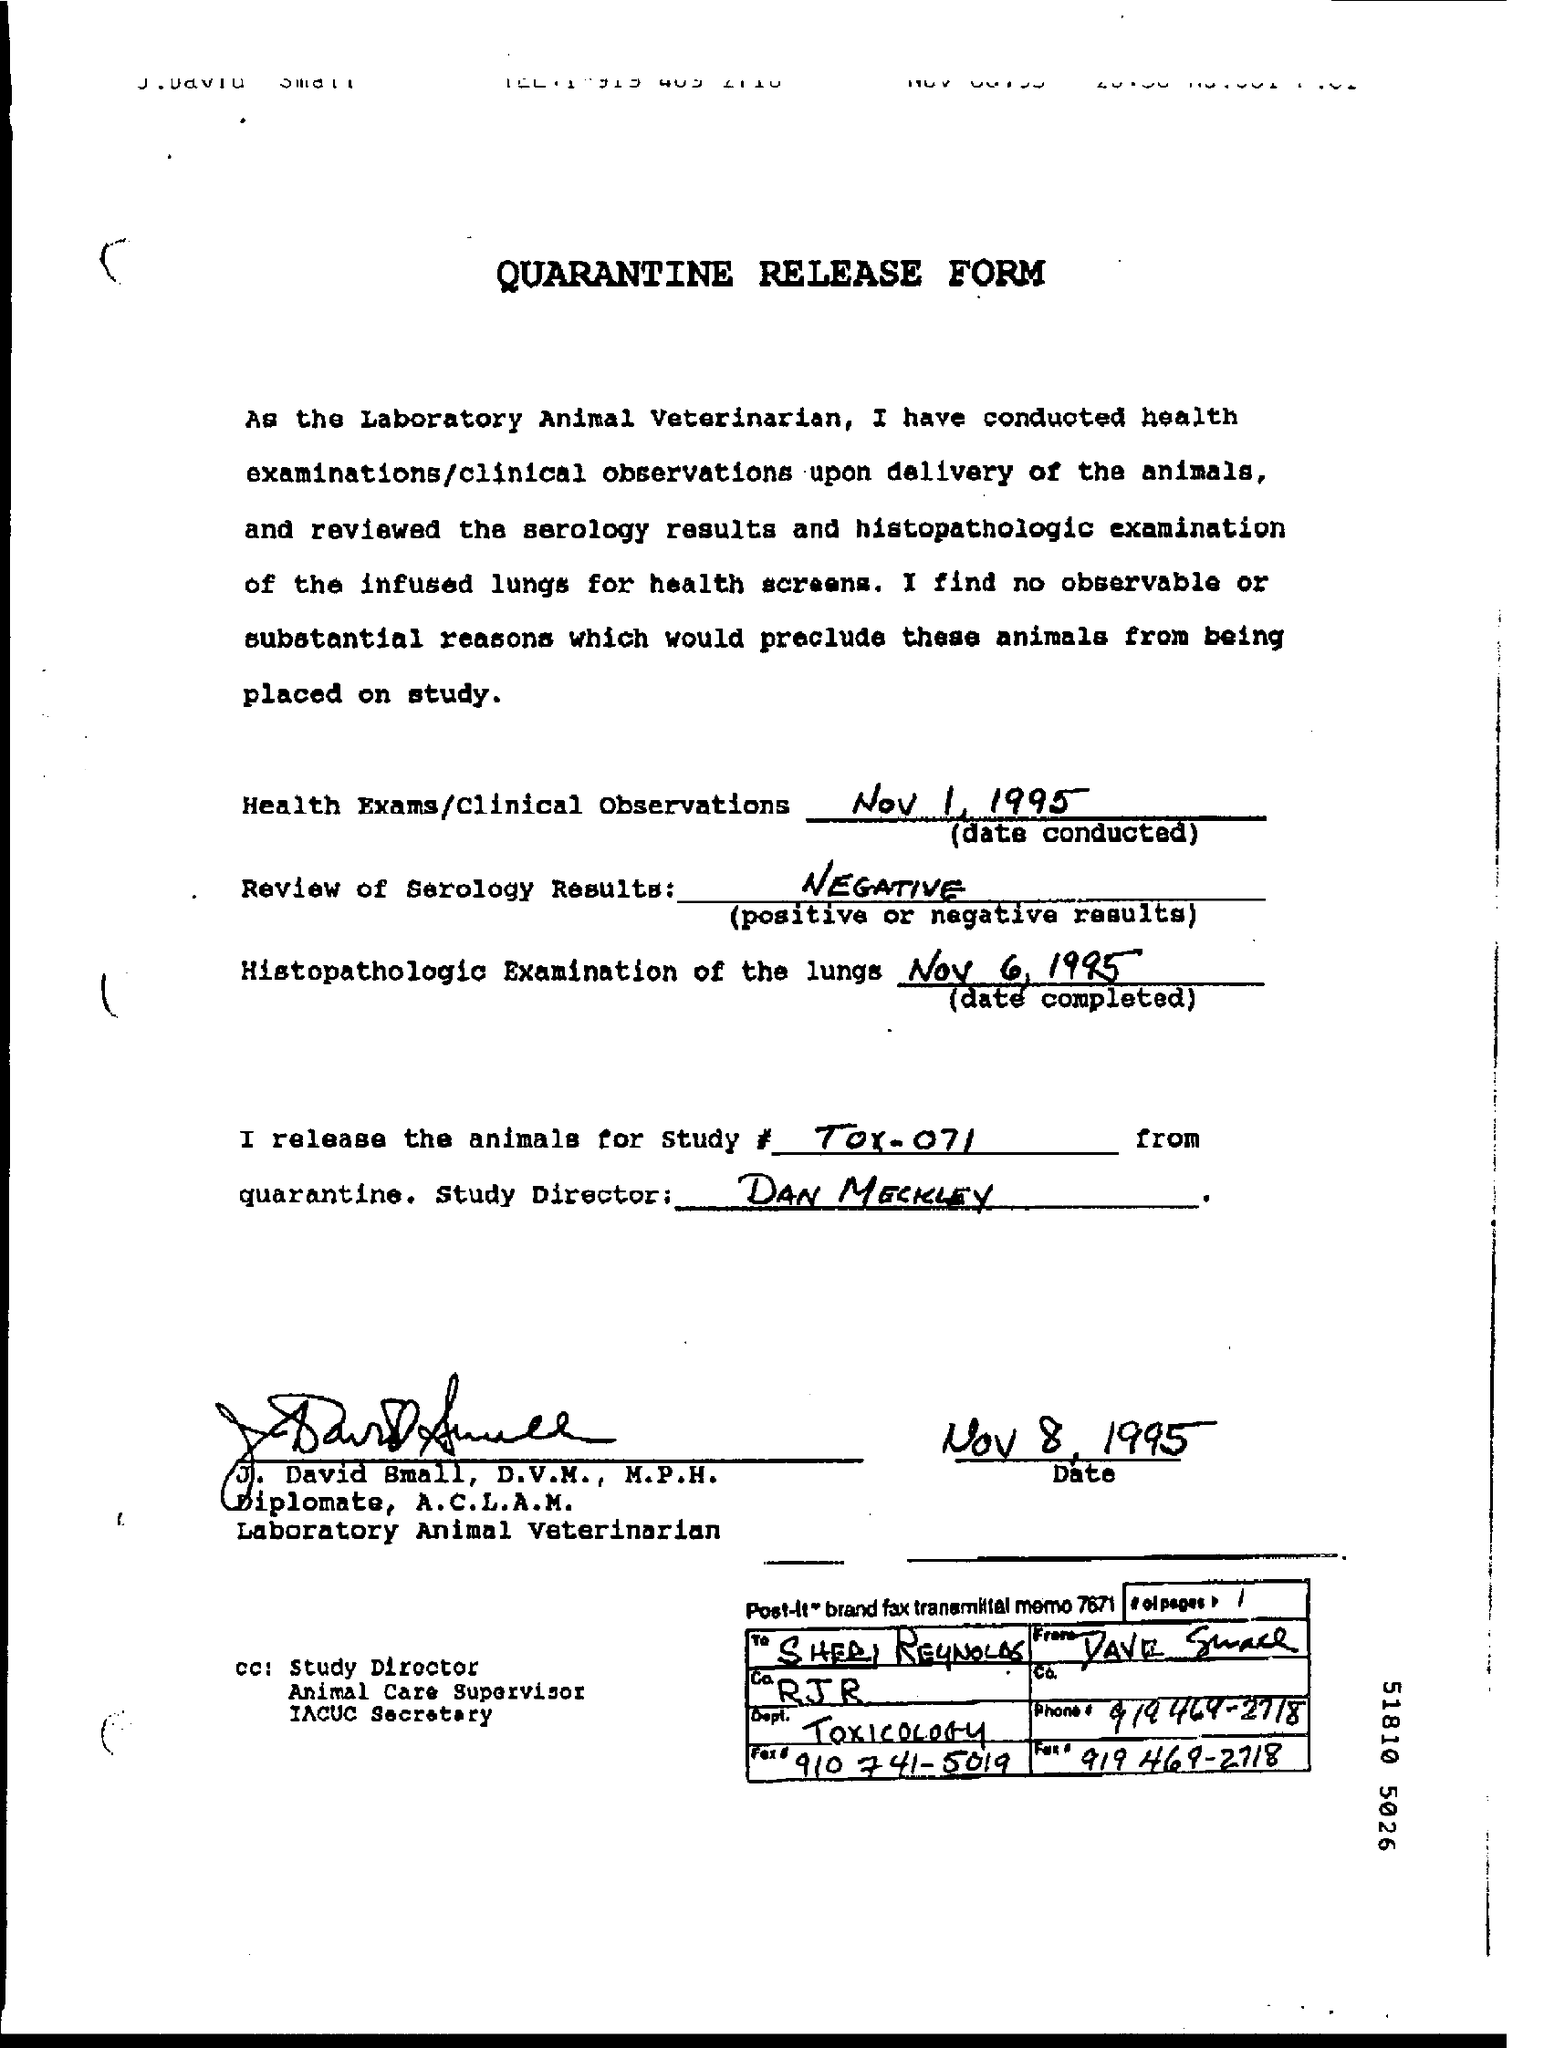What is the result of review of serology ?
Keep it short and to the point. NEGATIVE. On which date histopathologic examination of the lungs is completed ?
Ensure brevity in your answer.  NOV 6,1995. Who is the study director as mentioned in the form ?
Provide a succinct answer. Dan Meckley. On which date it was signed ?
Keep it short and to the point. Nov 8, 1995. To whom this release form has to be sent ?
Ensure brevity in your answer.  Sheri reynolds. What is the name of the dept as mentioned in the given form ?
Your answer should be compact. TOXICOLOGY. 